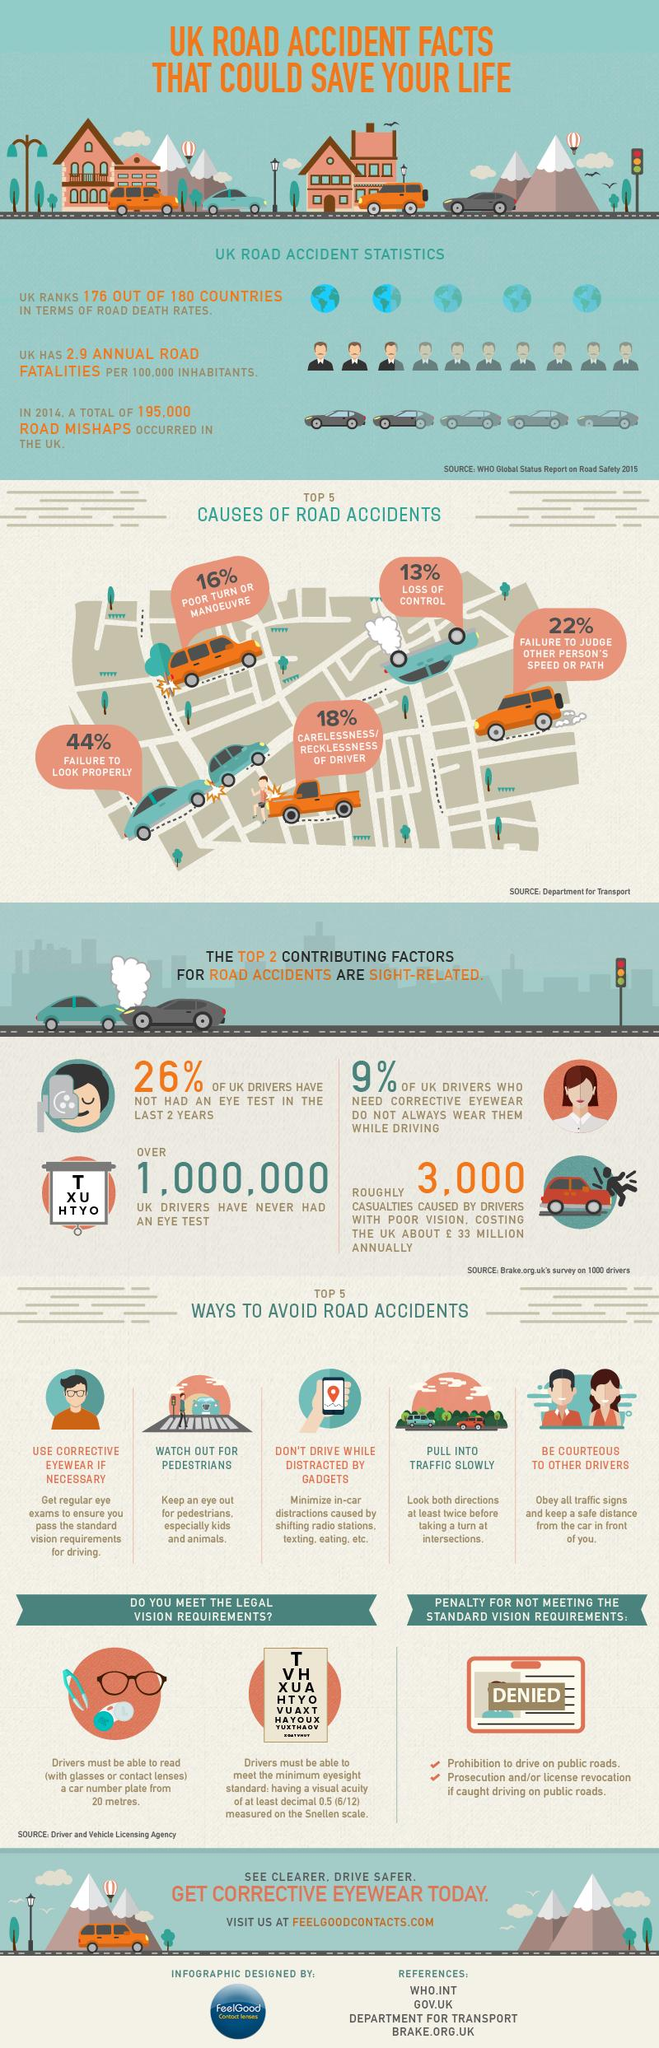Identify some key points in this picture. The top two contributing factors for road accidents that are sight-related are failure to look properly and failure to judge the speed and path of other individuals. According to recent statistics, a significant majority of UK drivers, or 74%, have had their eyes tested in the last 2 years. A poor turn is more likely to cause accidents than a loss of control, with a reported 3% increase in the former compared to the latter. According to the data, reckless driving was the cause of 18% of accidents. In the United Kingdom, failure to properly look while driving is the leading cause of road accidents. 